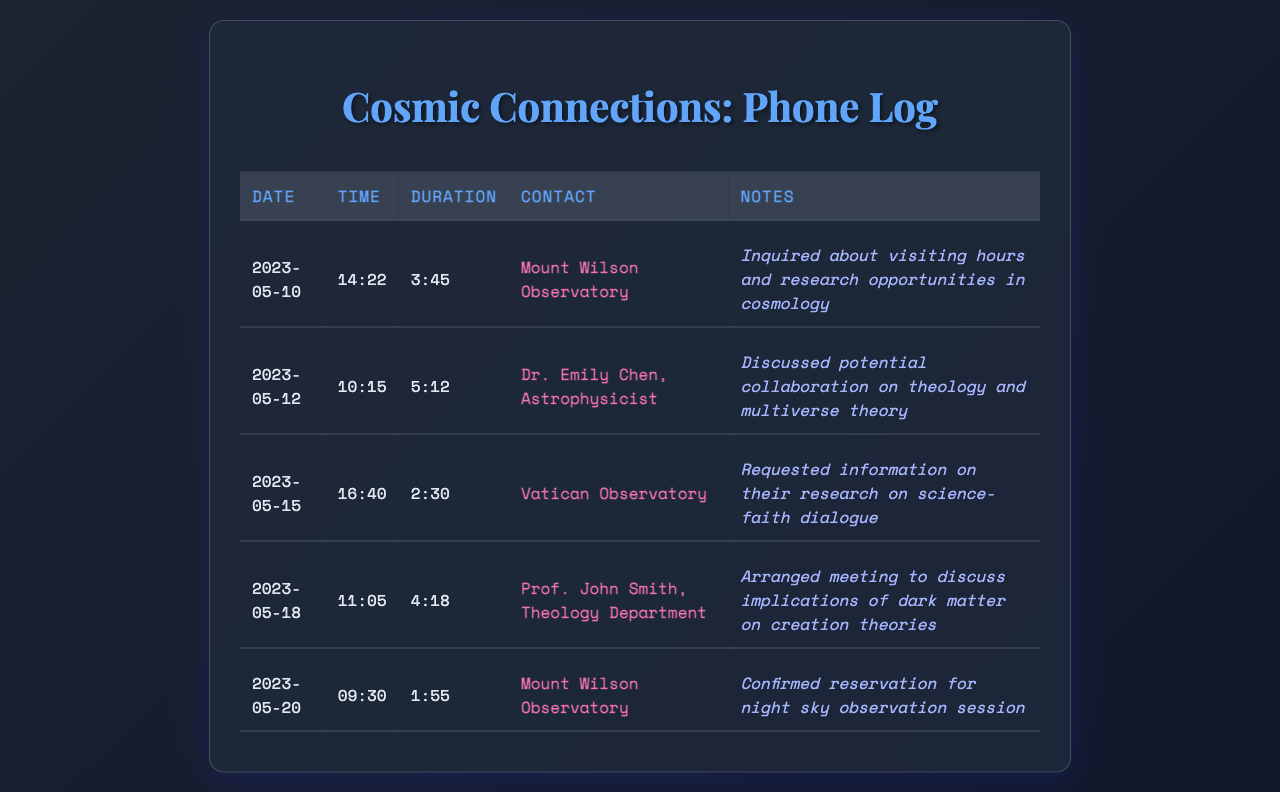What is the date of the first call? The first call is recorded on May 10, 2023.
Answer: May 10, 2023 Who was called on May 12, 2023? The contact on that date was Dr. Emily Chen, Astrophysicist.
Answer: Dr. Emily Chen, Astrophysicist What was the duration of the call with the Vatican Observatory? The duration of the call with the Vatican Observatory was 2:30.
Answer: 2:30 Which observatory confirmed a reservation for night sky observation? The observatory that confirmed the reservation was Mount Wilson Observatory.
Answer: Mount Wilson Observatory What topic was discussed with Prof. John Smith? The discussion topic was about the implications of dark matter on creation theories.
Answer: Implications of dark matter on creation theories How long was the call with Mount Wilson Observatory on May 10, 2023? The call duration was 3:45.
Answer: 3:45 Which contact's discussions involved theology and multiverse theory? The discussions involved Dr. Emily Chen.
Answer: Dr. Emily Chen How many calls were made to Mount Wilson Observatory? There were two calls made to Mount Wilson Observatory.
Answer: Two What was the purpose of the call with the Vatican Observatory? The purpose was to request information on their research on science-faith dialogue.
Answer: Request information on their research on science-faith dialogue 